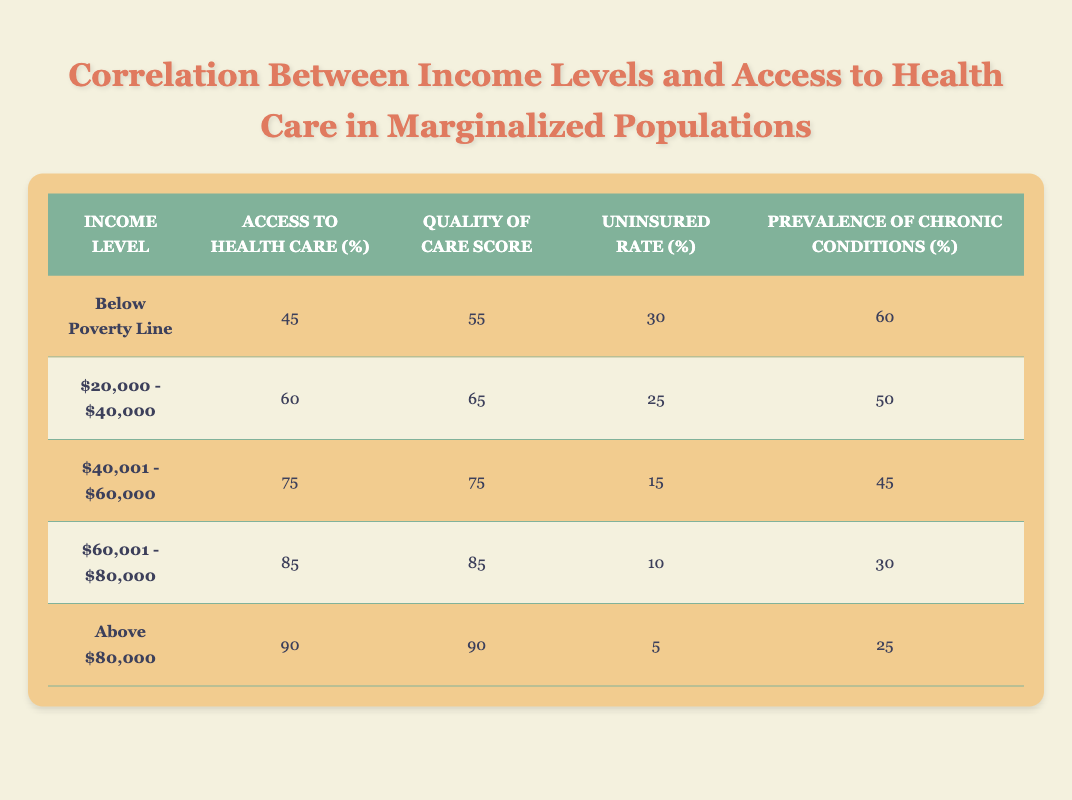What is the Access to Health Care percentage for those Below the Poverty Line? The row for "Below Poverty Line" shows an Access to Health Care percentage of 45.
Answer: 45 What is the Uninsured Rate for individuals earning between $20,000 and $40,000? The corresponding row for this income level indicates an Uninsured Rate of 25.
Answer: 25 Is the Quality of Care Score higher for those earning $60,001 to $80,000 compared to those earning between $40,001 and $60,000? The Quality of Care Score for those earning $60,001 to $80,000 is 85, while for $40,001 to $60,000, it is 75. Since 85 is greater than 75, the statement is true.
Answer: Yes What is the difference in Access to Health Care between individuals Below the Poverty Line and those Earning Above $80,000? The Access to Health Care for those Below the Poverty Line is 45, and for those Earning Above $80,000 is 90. The difference is 90 - 45 = 45.
Answer: 45 Which income level has the highest Uninsured Rate, and what is that rate? The row for "Below Poverty Line" shows an Uninsured Rate of 30, which is the highest rate listed in the table.
Answer: Below Poverty Line, 30 What is the average Quality of Care Score for the two lowest income brackets? The Quality of Care Scores for the two lowest income brackets are 55 (Below Poverty Line) and 65 ($20,000 - $40,000). The average is (55 + 65) / 2 = 120 / 2 = 60.
Answer: 60 Is it true that individuals earning between $20,000 and $40,000 are less likely to access health care compared to those earning between $40,001 and $60,000? The Access to Health Care percentage for $20,000 to $40,000 is 60, while for $40,001 to $60,000 it is 75. Since 60 is less than 75, the statement is true.
Answer: Yes What is the total Prevalence of Chronic Conditions for individuals earning below $40,000? The Prevalence of Chronic Conditions for those Below Poverty Line is 60, and for $20,000 to $40,000, it is 50. Their total is 60 + 50 = 110.
Answer: 110 How many income levels have an Access to Health Care percentage above 75? The income levels with Access to Health Care percentages above 75 are "$60,001 - $80,000" (85) and "Above $80,000" (90). Thus, there are 2 income levels.
Answer: 2 